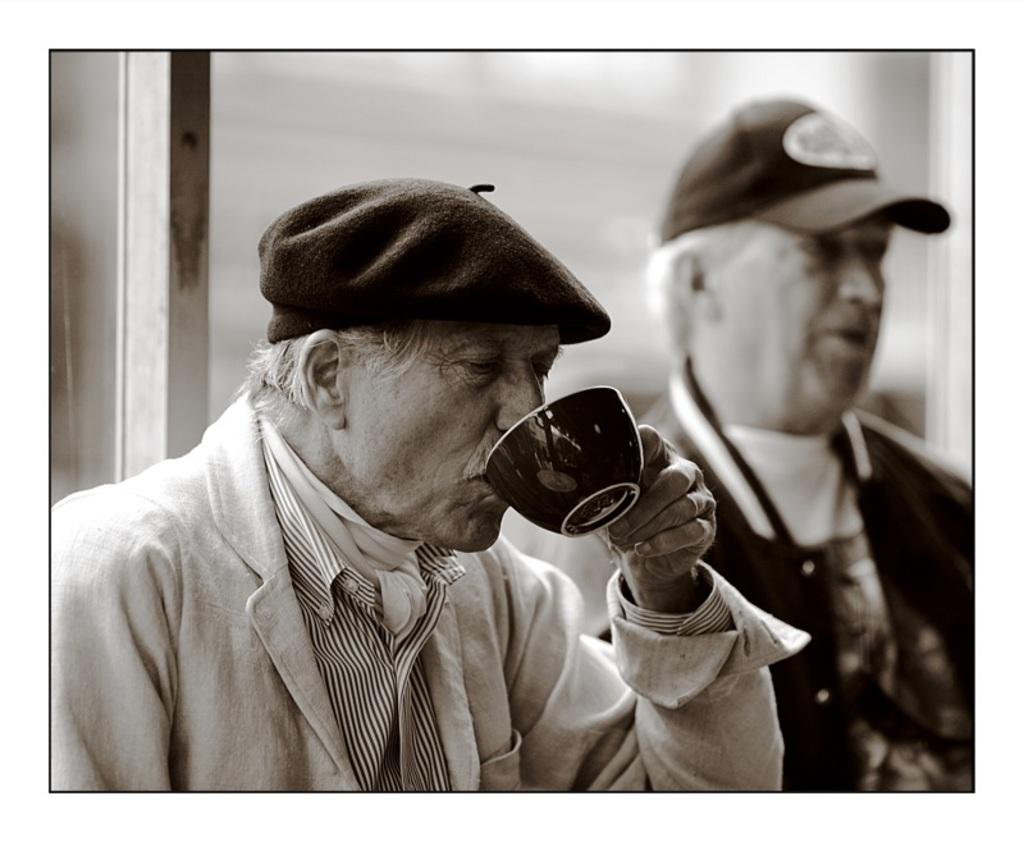What is the color scheme of the image? The image is black and white. How many people are in the image? There are two persons in the image. What is one of the persons holding? One of the persons is holding a cup. What type of grain is being selected by one of the persons in the image? There is no grain present in the image, and therefore no selection of grain is taking place. 